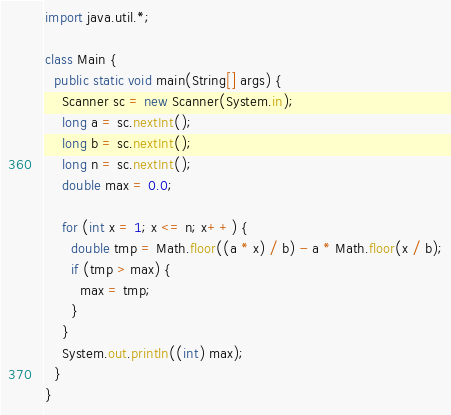<code> <loc_0><loc_0><loc_500><loc_500><_Java_>import java.util.*;

class Main {
  public static void main(String[] args) {
    Scanner sc = new Scanner(System.in);
    long a = sc.nextInt();
    long b = sc.nextInt();
    long n = sc.nextInt();
    double max = 0.0;

    for (int x = 1; x <= n; x++) {
      double tmp = Math.floor((a * x) / b) - a * Math.floor(x / b);
      if (tmp > max) {
        max = tmp;
      }
    }
    System.out.println((int) max);
  }
}</code> 